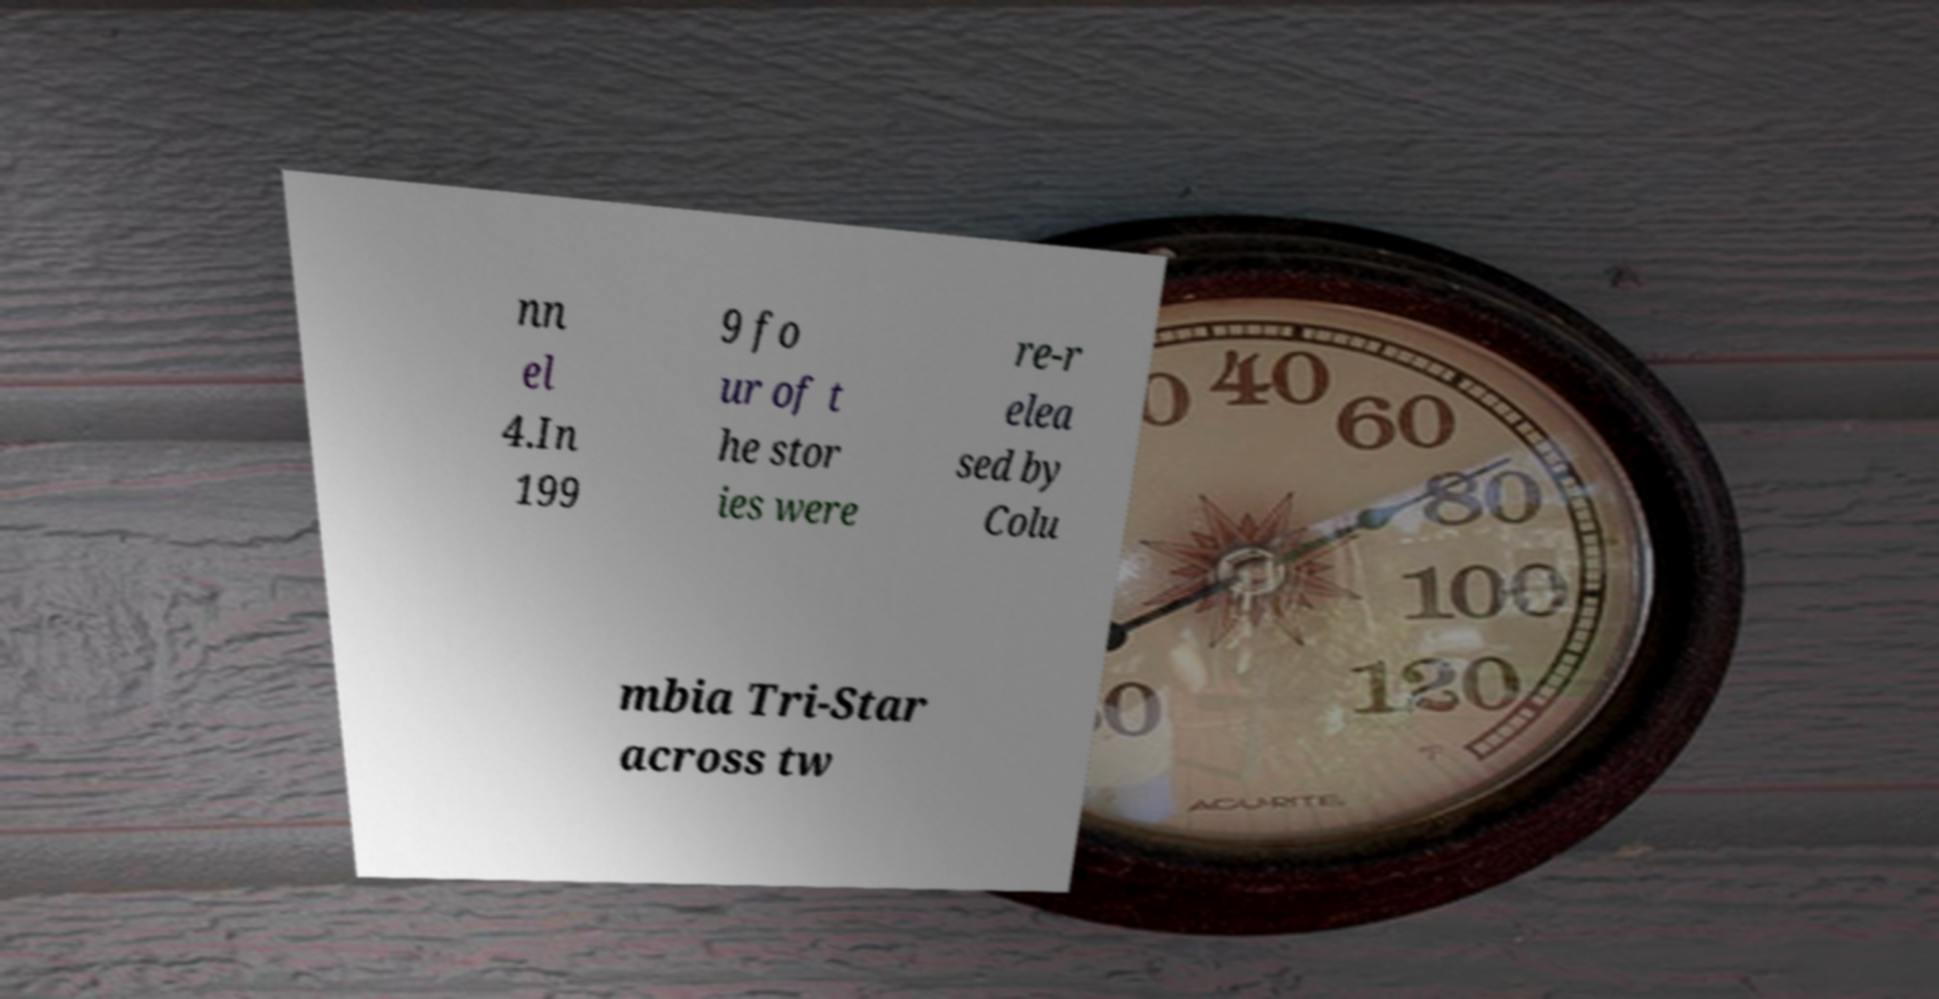Please identify and transcribe the text found in this image. nn el 4.In 199 9 fo ur of t he stor ies were re-r elea sed by Colu mbia Tri-Star across tw 